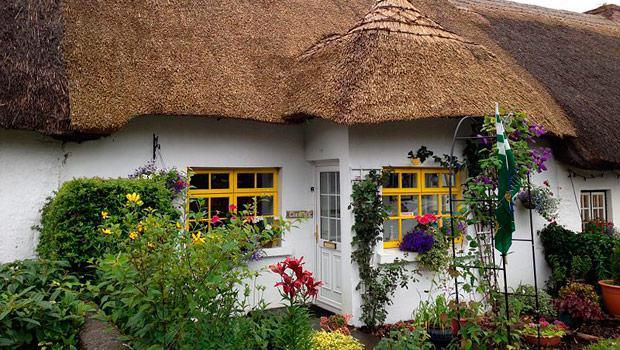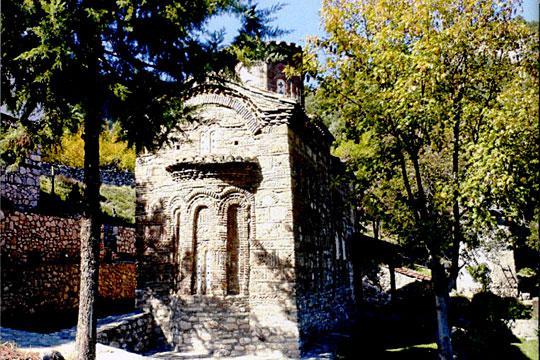The first image is the image on the left, the second image is the image on the right. For the images displayed, is the sentence "Each image shows the outside of a building, no statues or indoors." factually correct? Answer yes or no. Yes. The first image is the image on the left, the second image is the image on the right. Evaluate the accuracy of this statement regarding the images: "An image shows a string of colored flags suspended near a building with hills and trees behind it.". Is it true? Answer yes or no. No. 